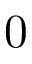Convert formula to latex. <formula><loc_0><loc_0><loc_500><loc_500>0</formula> 